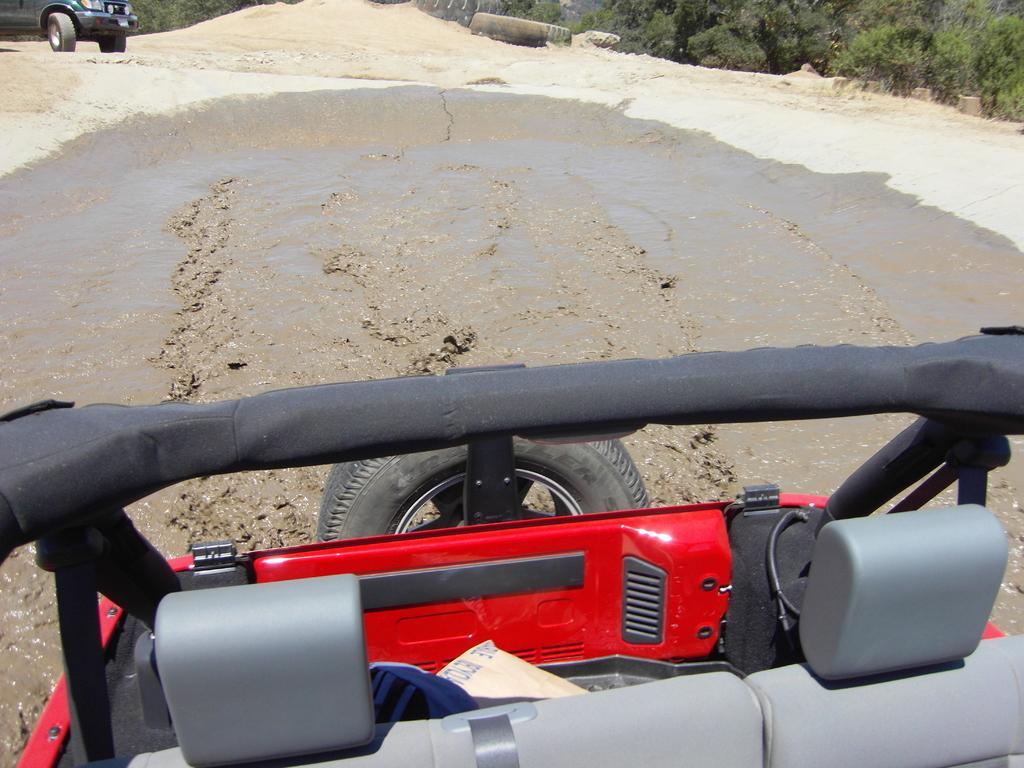How would you summarize this image in a sentence or two? In this image I can see a red colour vehicle and a wheel in the front. In the background I can see one more vehicle on the left side and I can also see number of trees on the right side. 